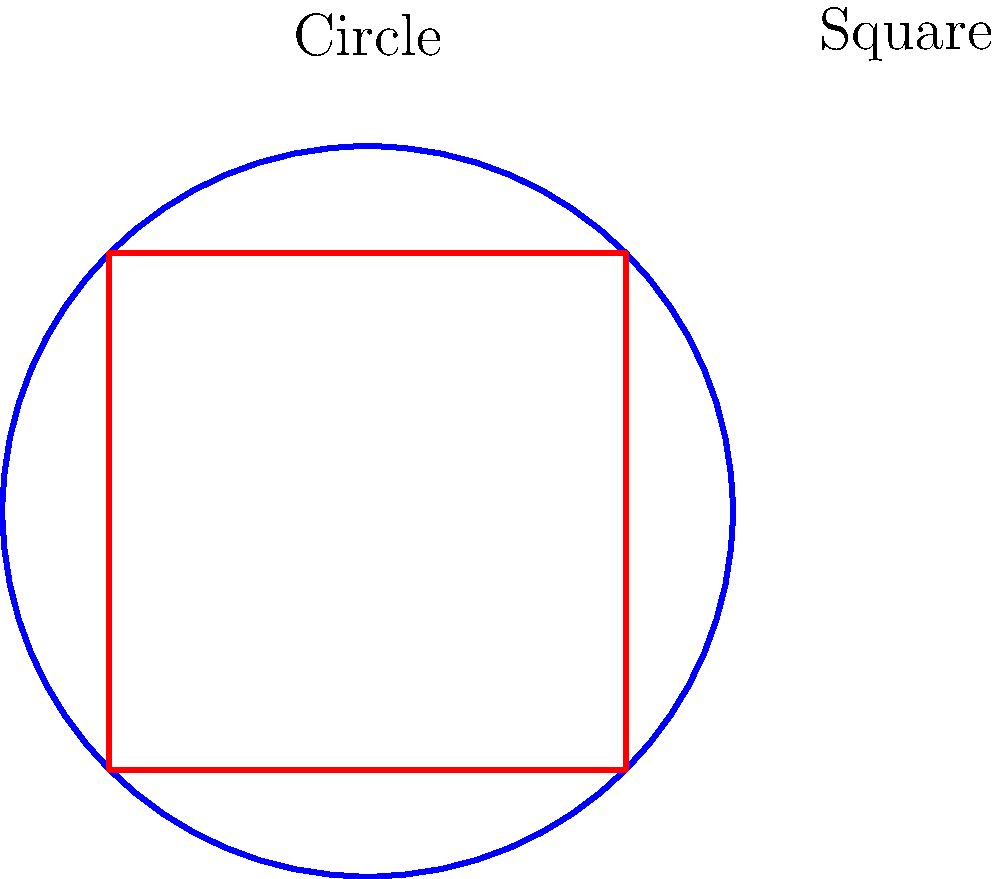As a software engineer optimizing a layout algorithm, you need to determine the most space-efficient way to arrange shapes within a square container. Given a square with side length $s$ and a circle with diameter $d$, where $d = s$, calculate the ratio of the area of the circle to the area of the square. How does this ratio relate to space efficiency, and what implications does it have for optimizing shape layouts? Let's approach this step-by-step:

1) The area of a square with side length $s$ is given by:
   $$A_s = s^2$$

2) The area of a circle with diameter $d$ is given by:
   $$A_c = \pi(\frac{d}{2})^2 = \pi(\frac{s}{2})^2 = \frac{\pi s^2}{4}$$

3) The ratio of the circle's area to the square's area is:
   $$\frac{A_c}{A_s} = \frac{\frac{\pi s^2}{4}}{s^2} = \frac{\pi}{4} \approx 0.7854$$

4) This means the circle occupies about 78.54% of the square's area.

5) The remaining space (about 21.46%) is wasted when fitting a circle into a square container.

6) Implications for optimizing shape layouts:
   - Circular shapes are less space-efficient when packed into square containers.
   - When designing layouts, using shapes that tessellate (like squares or hexagons) can lead to better space utilization.
   - In scenarios where circular shapes are necessary, consider using a hexagonal grid for more efficient packing.

7) For a software engineer optimizing layout algorithms:
   - Implement checks to identify and minimize wasted space.
   - Consider using space-filling curves or tessellating shapes for more efficient layouts.
   - Develop adaptive algorithms that can adjust shape arrangements based on container geometry.
Answer: $\frac{\pi}{4} \approx 0.7854$; circles waste ~21.46% space in square containers; use tessellating shapes for efficiency. 